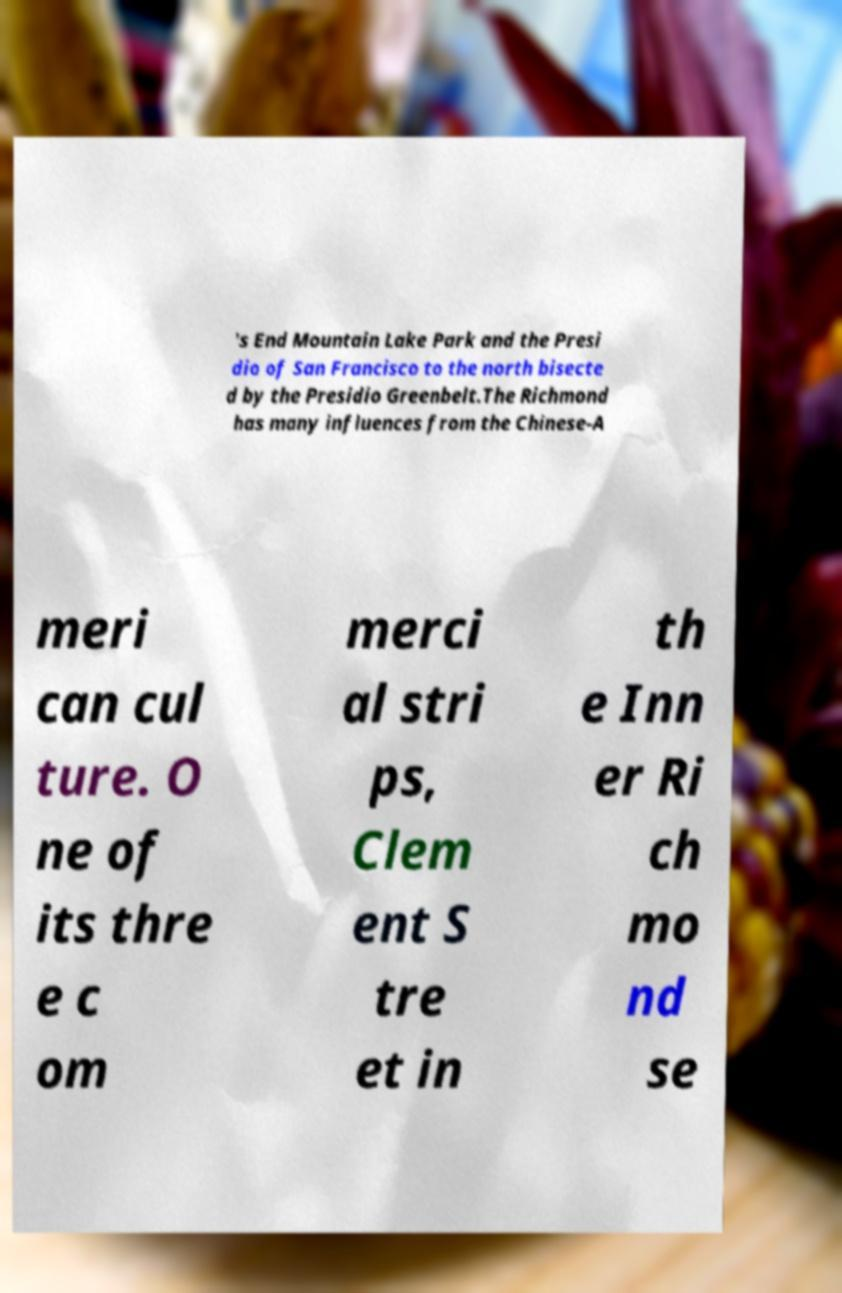Can you accurately transcribe the text from the provided image for me? 's End Mountain Lake Park and the Presi dio of San Francisco to the north bisecte d by the Presidio Greenbelt.The Richmond has many influences from the Chinese-A meri can cul ture. O ne of its thre e c om merci al stri ps, Clem ent S tre et in th e Inn er Ri ch mo nd se 